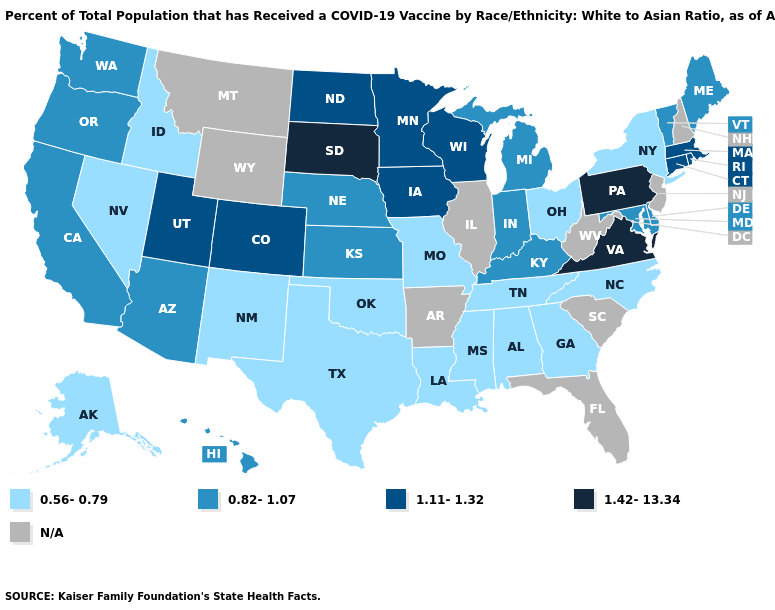What is the value of Oklahoma?
Answer briefly. 0.56-0.79. What is the lowest value in the USA?
Short answer required. 0.56-0.79. What is the value of Virginia?
Keep it brief. 1.42-13.34. What is the lowest value in states that border Delaware?
Answer briefly. 0.82-1.07. Which states hav the highest value in the West?
Be succinct. Colorado, Utah. What is the lowest value in the USA?
Write a very short answer. 0.56-0.79. Among the states that border New Mexico , which have the lowest value?
Write a very short answer. Oklahoma, Texas. Is the legend a continuous bar?
Be succinct. No. Name the states that have a value in the range 1.11-1.32?
Quick response, please. Colorado, Connecticut, Iowa, Massachusetts, Minnesota, North Dakota, Rhode Island, Utah, Wisconsin. Name the states that have a value in the range 1.11-1.32?
Answer briefly. Colorado, Connecticut, Iowa, Massachusetts, Minnesota, North Dakota, Rhode Island, Utah, Wisconsin. Is the legend a continuous bar?
Answer briefly. No. What is the value of Rhode Island?
Short answer required. 1.11-1.32. What is the value of North Dakota?
Keep it brief. 1.11-1.32. Name the states that have a value in the range 1.42-13.34?
Answer briefly. Pennsylvania, South Dakota, Virginia. 